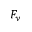<formula> <loc_0><loc_0><loc_500><loc_500>F _ { y }</formula> 